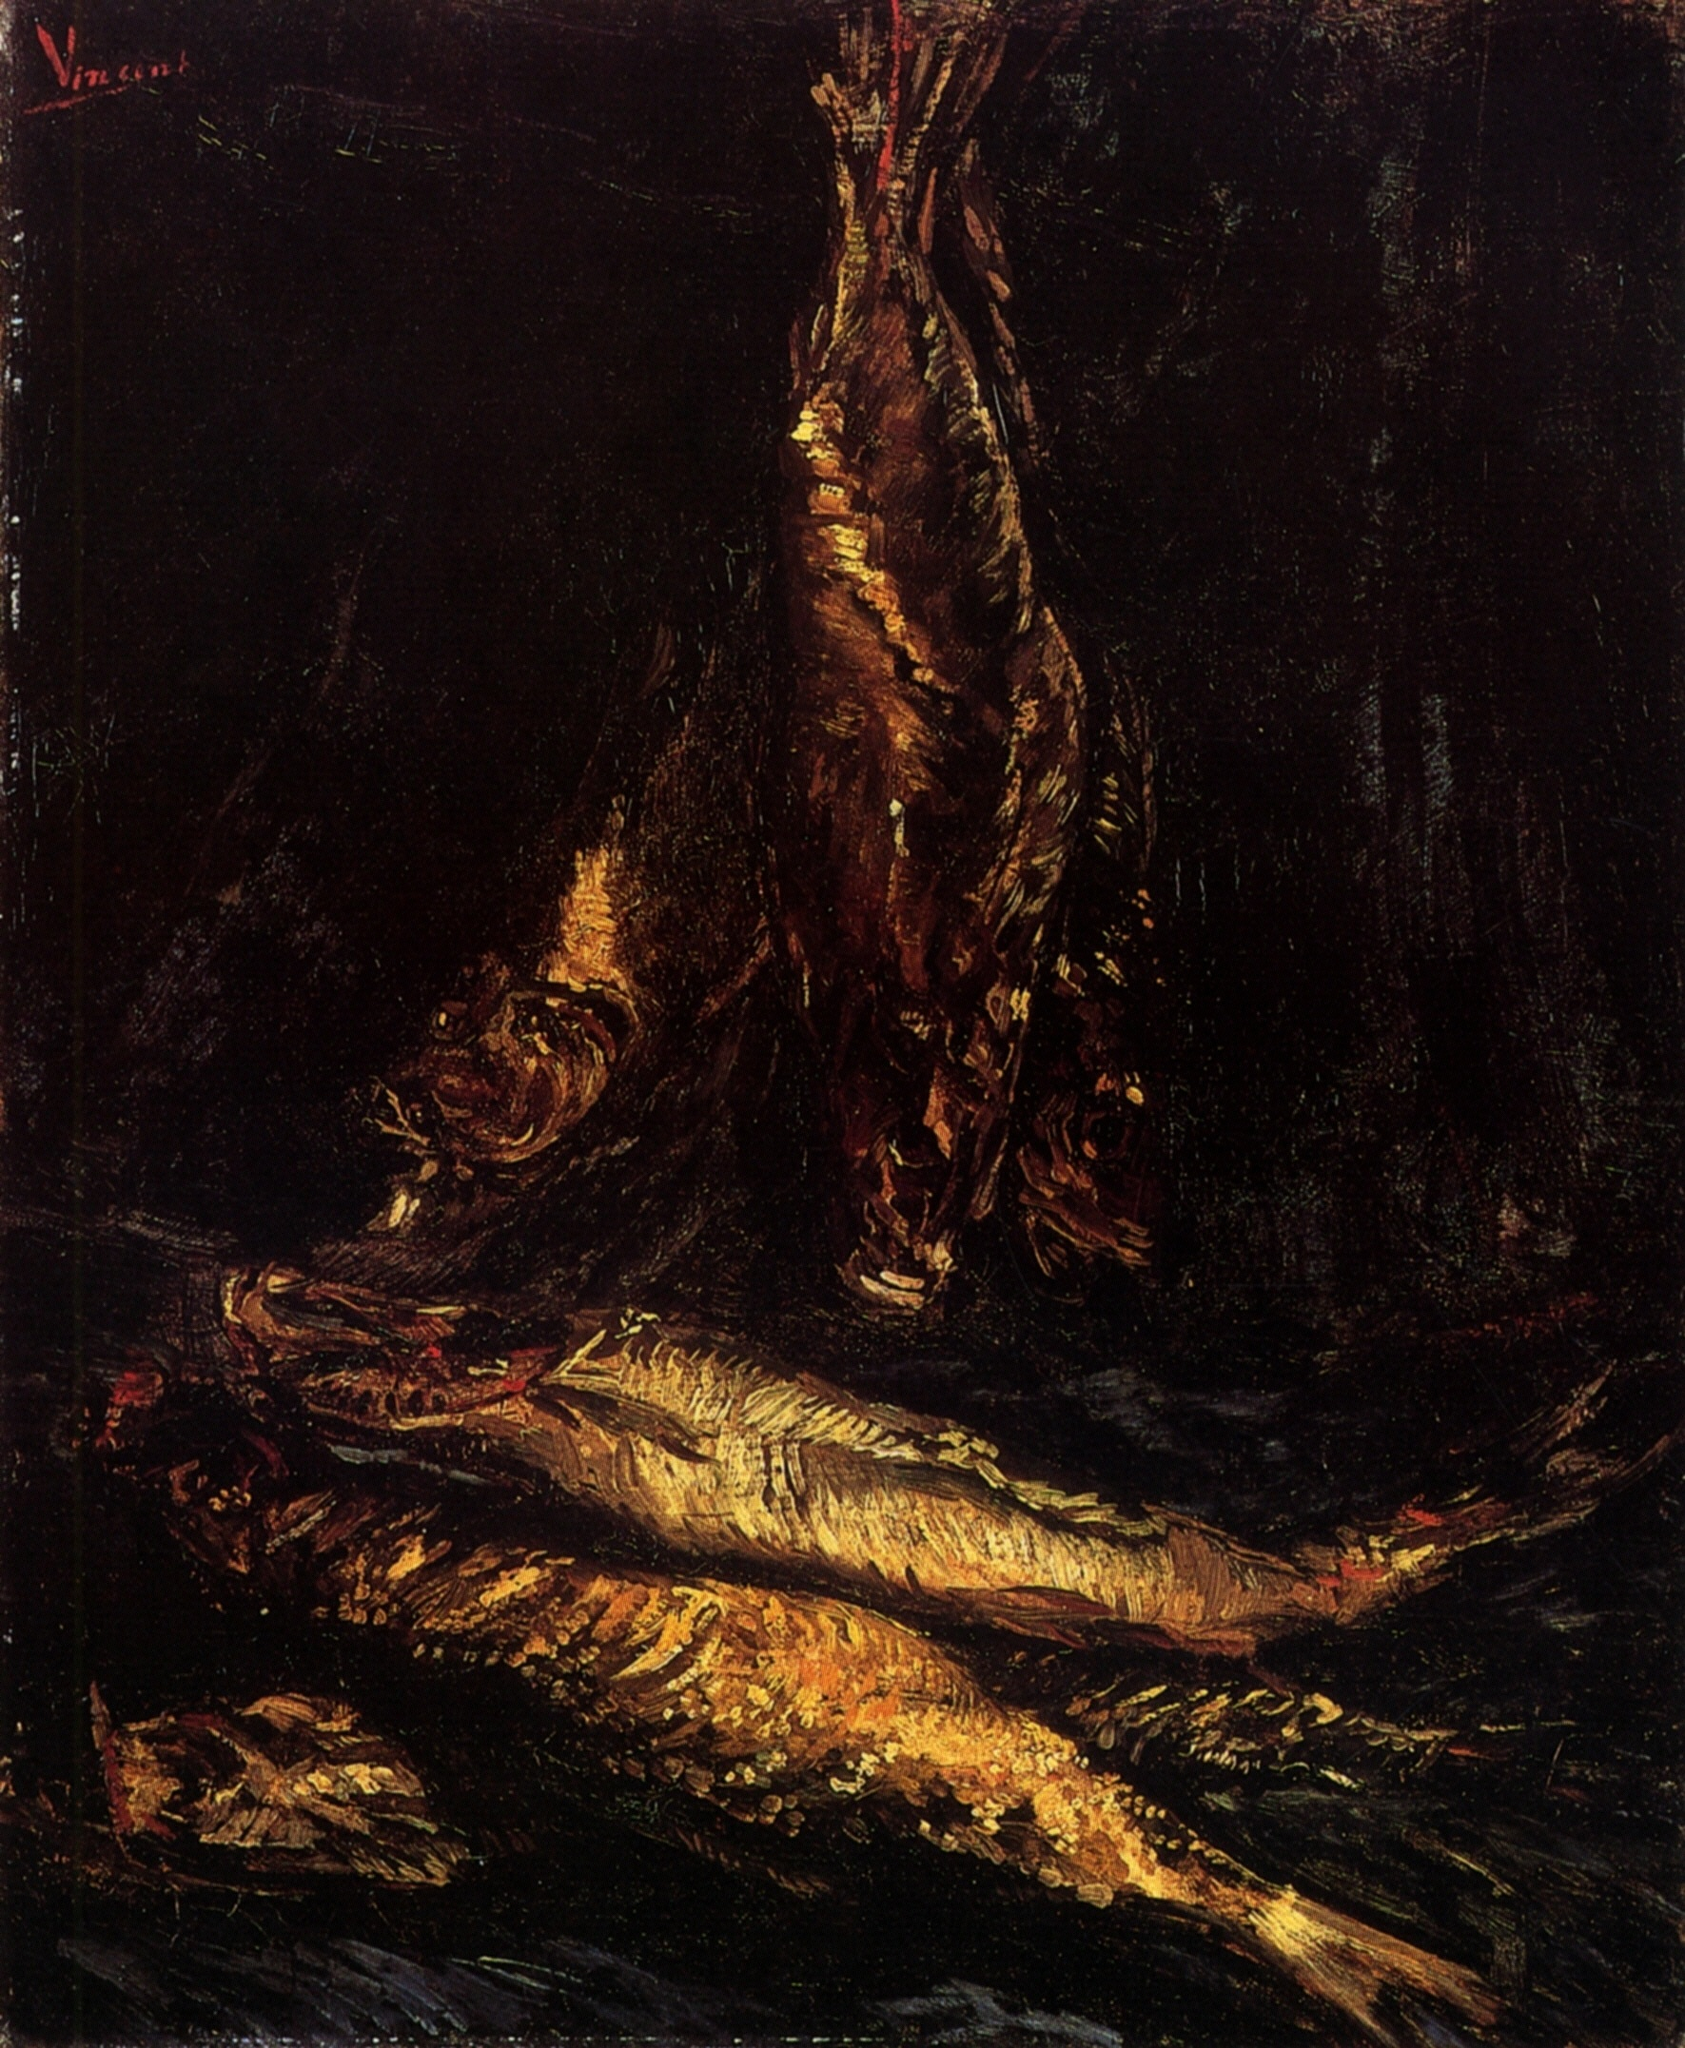What emotions does this art piece evoke and why? The art piece evokes a melancholic and somber mood, underscored by the dark palette and the depiction of lifeless fish. This emotion is intensified by the stark contrast between the vitality suggested by the fish's shimmering scales and their actual lifeless state. The use of shadow and limited light sources focuses the viewer on the mortality and transient beauty of natural forms, reflecting deeper themes of life and death. 